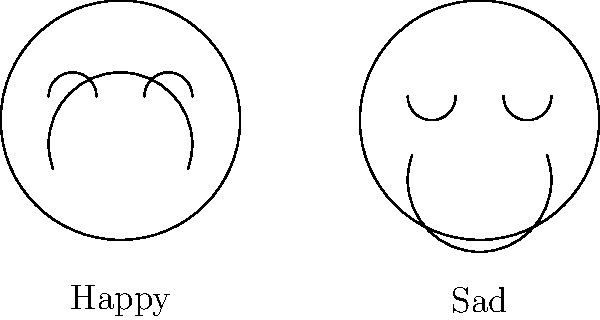Consider the facial expressions of two cartoon characters: one with a happy expression and another with a sad expression, as shown in the diagram. Are these two facial expressions homeomorphic to each other? Explain your reasoning using topological concepts. To determine if the two facial expressions are homeomorphic, we need to consider the following steps:

1. Definition of homeomorphism: Two topological spaces are homeomorphic if there exists a continuous bijective function with a continuous inverse between them.

2. Analyze the facial features:
   a) Both faces have a circular boundary (head shape).
   b) Both faces have two eyes and one mouth.

3. Consider the arrangement of features:
   a) The eyes in both expressions are in the same relative positions.
   b) The mouths in both expressions are in different positions and have different curvatures.

4. Topological equivalence:
   a) The number and relative positions of features (eyes and mouth) are preserved.
   b) The shapes can be continuously deformed into each other without cutting or gluing.

5. Continuous deformation:
   a) The happy mouth can be continuously deformed into the sad mouth by moving the corners downward and changing the curvature.
   b) The happy eyes can be continuously deformed into the sad eyes by inverting the curvature of the arcs.

6. Bijective mapping:
   There exists a one-to-one correspondence between points on the happy face and points on the sad face.

7. Continuity:
   The deformation from one expression to the other can be done continuously, preserving the neighborhood relationships of points.

Given these considerations, we can conclude that the two facial expressions are indeed homeomorphic to each other. The differences in appearance are due to continuous deformations of the same underlying topological structure.
Answer: Yes, the facial expressions are homeomorphic. 